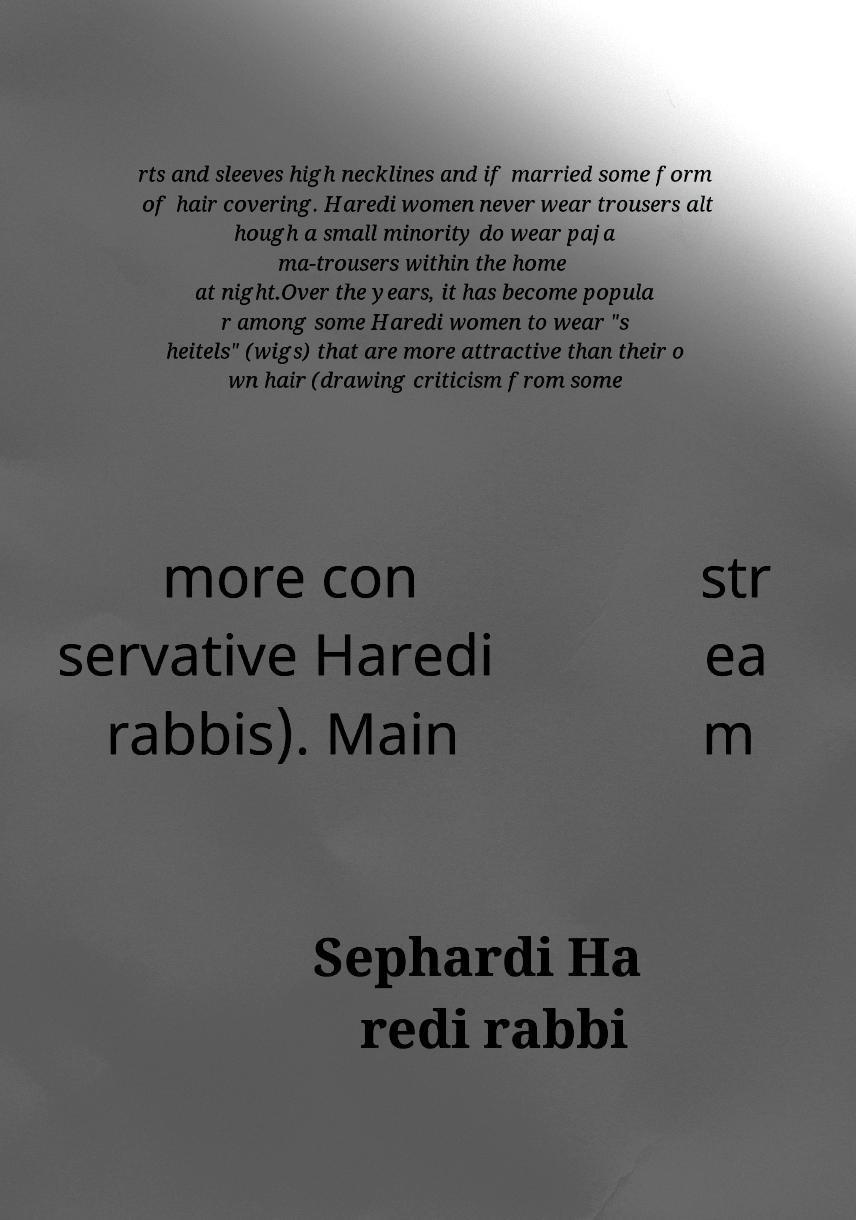Could you assist in decoding the text presented in this image and type it out clearly? rts and sleeves high necklines and if married some form of hair covering. Haredi women never wear trousers alt hough a small minority do wear paja ma-trousers within the home at night.Over the years, it has become popula r among some Haredi women to wear "s heitels" (wigs) that are more attractive than their o wn hair (drawing criticism from some more con servative Haredi rabbis). Main str ea m Sephardi Ha redi rabbi 